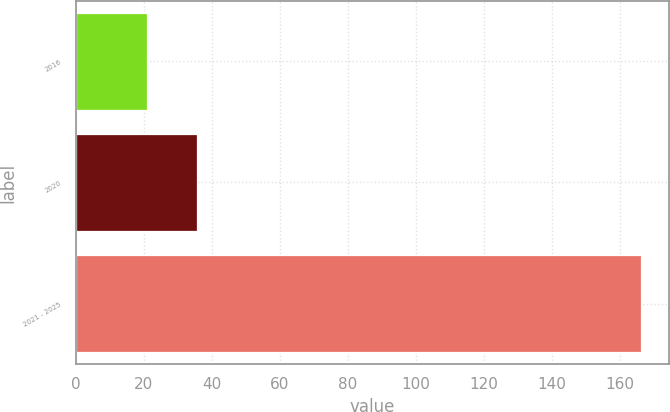Convert chart to OTSL. <chart><loc_0><loc_0><loc_500><loc_500><bar_chart><fcel>2016<fcel>2020<fcel>2021 - 2025<nl><fcel>21<fcel>35.5<fcel>166<nl></chart> 